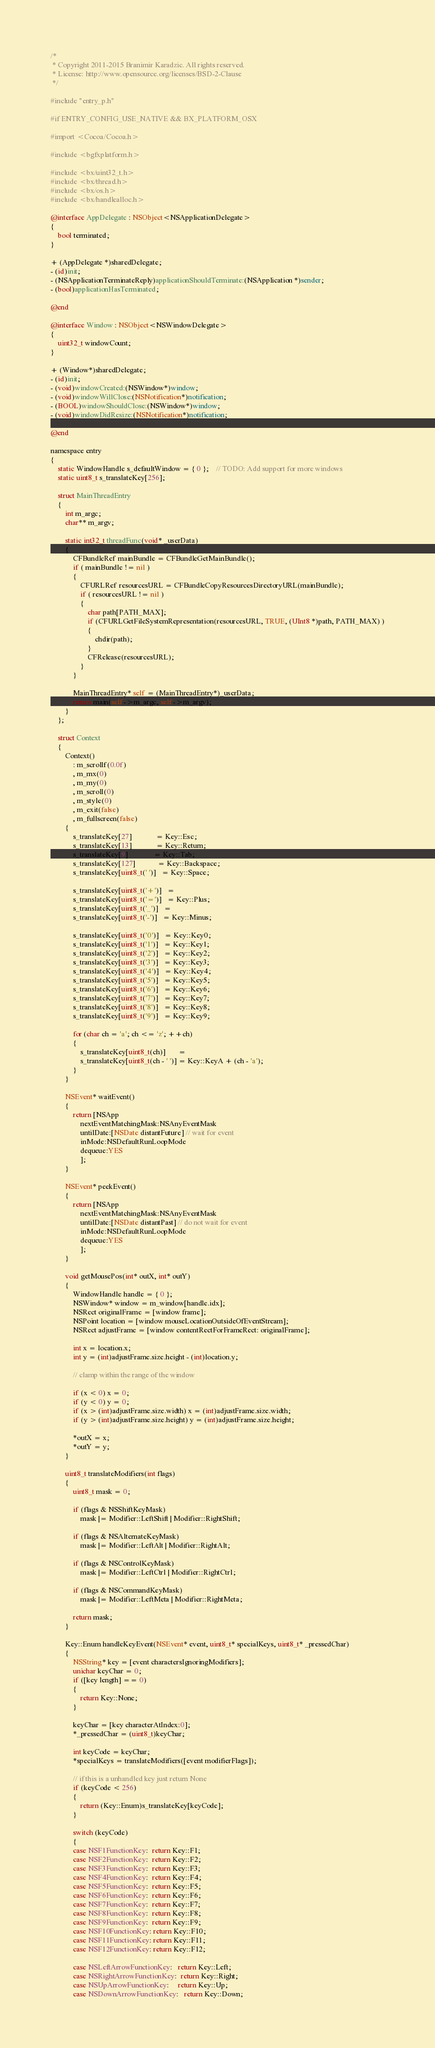<code> <loc_0><loc_0><loc_500><loc_500><_ObjectiveC_>/*
 * Copyright 2011-2015 Branimir Karadzic. All rights reserved.
 * License: http://www.opensource.org/licenses/BSD-2-Clause
 */

#include "entry_p.h"

#if ENTRY_CONFIG_USE_NATIVE && BX_PLATFORM_OSX

#import <Cocoa/Cocoa.h>

#include <bgfxplatform.h>

#include <bx/uint32_t.h>
#include <bx/thread.h>
#include <bx/os.h>
#include <bx/handlealloc.h>

@interface AppDelegate : NSObject<NSApplicationDelegate>
{
	bool terminated;
}

+ (AppDelegate *)sharedDelegate;
- (id)init;
- (NSApplicationTerminateReply)applicationShouldTerminate:(NSApplication *)sender;
- (bool)applicationHasTerminated;

@end

@interface Window : NSObject<NSWindowDelegate>
{
	uint32_t windowCount;
}

+ (Window*)sharedDelegate;
- (id)init;
- (void)windowCreated:(NSWindow*)window;
- (void)windowWillClose:(NSNotification*)notification;
- (BOOL)windowShouldClose:(NSWindow*)window;
- (void)windowDidResize:(NSNotification*)notification;

@end

namespace entry
{
	static WindowHandle s_defaultWindow = { 0 };	// TODO: Add support for more windows
	static uint8_t s_translateKey[256];

	struct MainThreadEntry
	{
		int m_argc;
		char** m_argv;

		static int32_t threadFunc(void* _userData)
		{
			CFBundleRef mainBundle = CFBundleGetMainBundle();
			if ( mainBundle != nil )
			{
				CFURLRef resourcesURL = CFBundleCopyResourcesDirectoryURL(mainBundle);
				if ( resourcesURL != nil )
				{
					char path[PATH_MAX];
					if (CFURLGetFileSystemRepresentation(resourcesURL, TRUE, (UInt8 *)path, PATH_MAX) )
					{
						chdir(path);
					}
					CFRelease(resourcesURL);
				}
			}

			MainThreadEntry* self = (MainThreadEntry*)_userData;
			return main(self->m_argc, self->m_argv);
		}
	};

	struct Context
	{
		Context()
			: m_scrollf(0.0f)
			, m_mx(0)
			, m_my(0)
			, m_scroll(0)
			, m_style(0)
			, m_exit(false)
			, m_fullscreen(false)
		{
			s_translateKey[27]             = Key::Esc;
			s_translateKey[13]             = Key::Return;
			s_translateKey[9]              = Key::Tab;
			s_translateKey[127]            = Key::Backspace;
			s_translateKey[uint8_t(' ')]   = Key::Space;

			s_translateKey[uint8_t('+')]   =
			s_translateKey[uint8_t('=')]   = Key::Plus;
			s_translateKey[uint8_t('_')]   =
			s_translateKey[uint8_t('-')]   = Key::Minus;

			s_translateKey[uint8_t('0')]   = Key::Key0;
			s_translateKey[uint8_t('1')]   = Key::Key1;
			s_translateKey[uint8_t('2')]   = Key::Key2;
			s_translateKey[uint8_t('3')]   = Key::Key3;
			s_translateKey[uint8_t('4')]   = Key::Key4;
			s_translateKey[uint8_t('5')]   = Key::Key5;
			s_translateKey[uint8_t('6')]   = Key::Key6;
			s_translateKey[uint8_t('7')]   = Key::Key7;
			s_translateKey[uint8_t('8')]   = Key::Key8;
			s_translateKey[uint8_t('9')]   = Key::Key9;

			for (char ch = 'a'; ch <= 'z'; ++ch)
			{
				s_translateKey[uint8_t(ch)]       =
				s_translateKey[uint8_t(ch - ' ')] = Key::KeyA + (ch - 'a');
			}
		}

		NSEvent* waitEvent()
		{
			return [NSApp
				nextEventMatchingMask:NSAnyEventMask
				untilDate:[NSDate distantFuture] // wait for event
				inMode:NSDefaultRunLoopMode
				dequeue:YES
				];
		}

		NSEvent* peekEvent()
		{
			return [NSApp
				nextEventMatchingMask:NSAnyEventMask
				untilDate:[NSDate distantPast] // do not wait for event
				inMode:NSDefaultRunLoopMode
				dequeue:YES
				];
		}

		void getMousePos(int* outX, int* outY)
		{
			WindowHandle handle = { 0 };
			NSWindow* window = m_window[handle.idx];
			NSRect originalFrame = [window frame];
			NSPoint location = [window mouseLocationOutsideOfEventStream];
			NSRect adjustFrame = [window contentRectForFrameRect: originalFrame];

			int x = location.x;
			int y = (int)adjustFrame.size.height - (int)location.y;

			// clamp within the range of the window

			if (x < 0) x = 0;
			if (y < 0) y = 0;
			if (x > (int)adjustFrame.size.width) x = (int)adjustFrame.size.width;
			if (y > (int)adjustFrame.size.height) y = (int)adjustFrame.size.height;

			*outX = x;
			*outY = y;
		}

		uint8_t translateModifiers(int flags)
		{
			uint8_t mask = 0;

			if (flags & NSShiftKeyMask)
				mask |= Modifier::LeftShift | Modifier::RightShift;

			if (flags & NSAlternateKeyMask)
				mask |= Modifier::LeftAlt | Modifier::RightAlt;

			if (flags & NSControlKeyMask)
				mask |= Modifier::LeftCtrl | Modifier::RightCtrl;

			if (flags & NSCommandKeyMask)
				mask |= Modifier::LeftMeta | Modifier::RightMeta;

			return mask;
		}

		Key::Enum handleKeyEvent(NSEvent* event, uint8_t* specialKeys, uint8_t* _pressedChar)
		{
			NSString* key = [event charactersIgnoringModifiers];
			unichar keyChar = 0;
			if ([key length] == 0)
			{
				return Key::None;
			}

			keyChar = [key characterAtIndex:0];
			*_pressedChar = (uint8_t)keyChar;

			int keyCode = keyChar;
			*specialKeys = translateModifiers([event modifierFlags]);

			// if this is a unhandled key just return None
			if (keyCode < 256)
			{
				return (Key::Enum)s_translateKey[keyCode];
			}

			switch (keyCode)
			{
			case NSF1FunctionKey:  return Key::F1;
			case NSF2FunctionKey:  return Key::F2;
			case NSF3FunctionKey:  return Key::F3;
			case NSF4FunctionKey:  return Key::F4;
			case NSF5FunctionKey:  return Key::F5;
			case NSF6FunctionKey:  return Key::F6;
			case NSF7FunctionKey:  return Key::F7;
			case NSF8FunctionKey:  return Key::F8;
			case NSF9FunctionKey:  return Key::F9;
			case NSF10FunctionKey: return Key::F10;
			case NSF11FunctionKey: return Key::F11;
			case NSF12FunctionKey: return Key::F12;

			case NSLeftArrowFunctionKey:   return Key::Left;
			case NSRightArrowFunctionKey:  return Key::Right;
			case NSUpArrowFunctionKey:     return Key::Up;
			case NSDownArrowFunctionKey:   return Key::Down;
</code> 